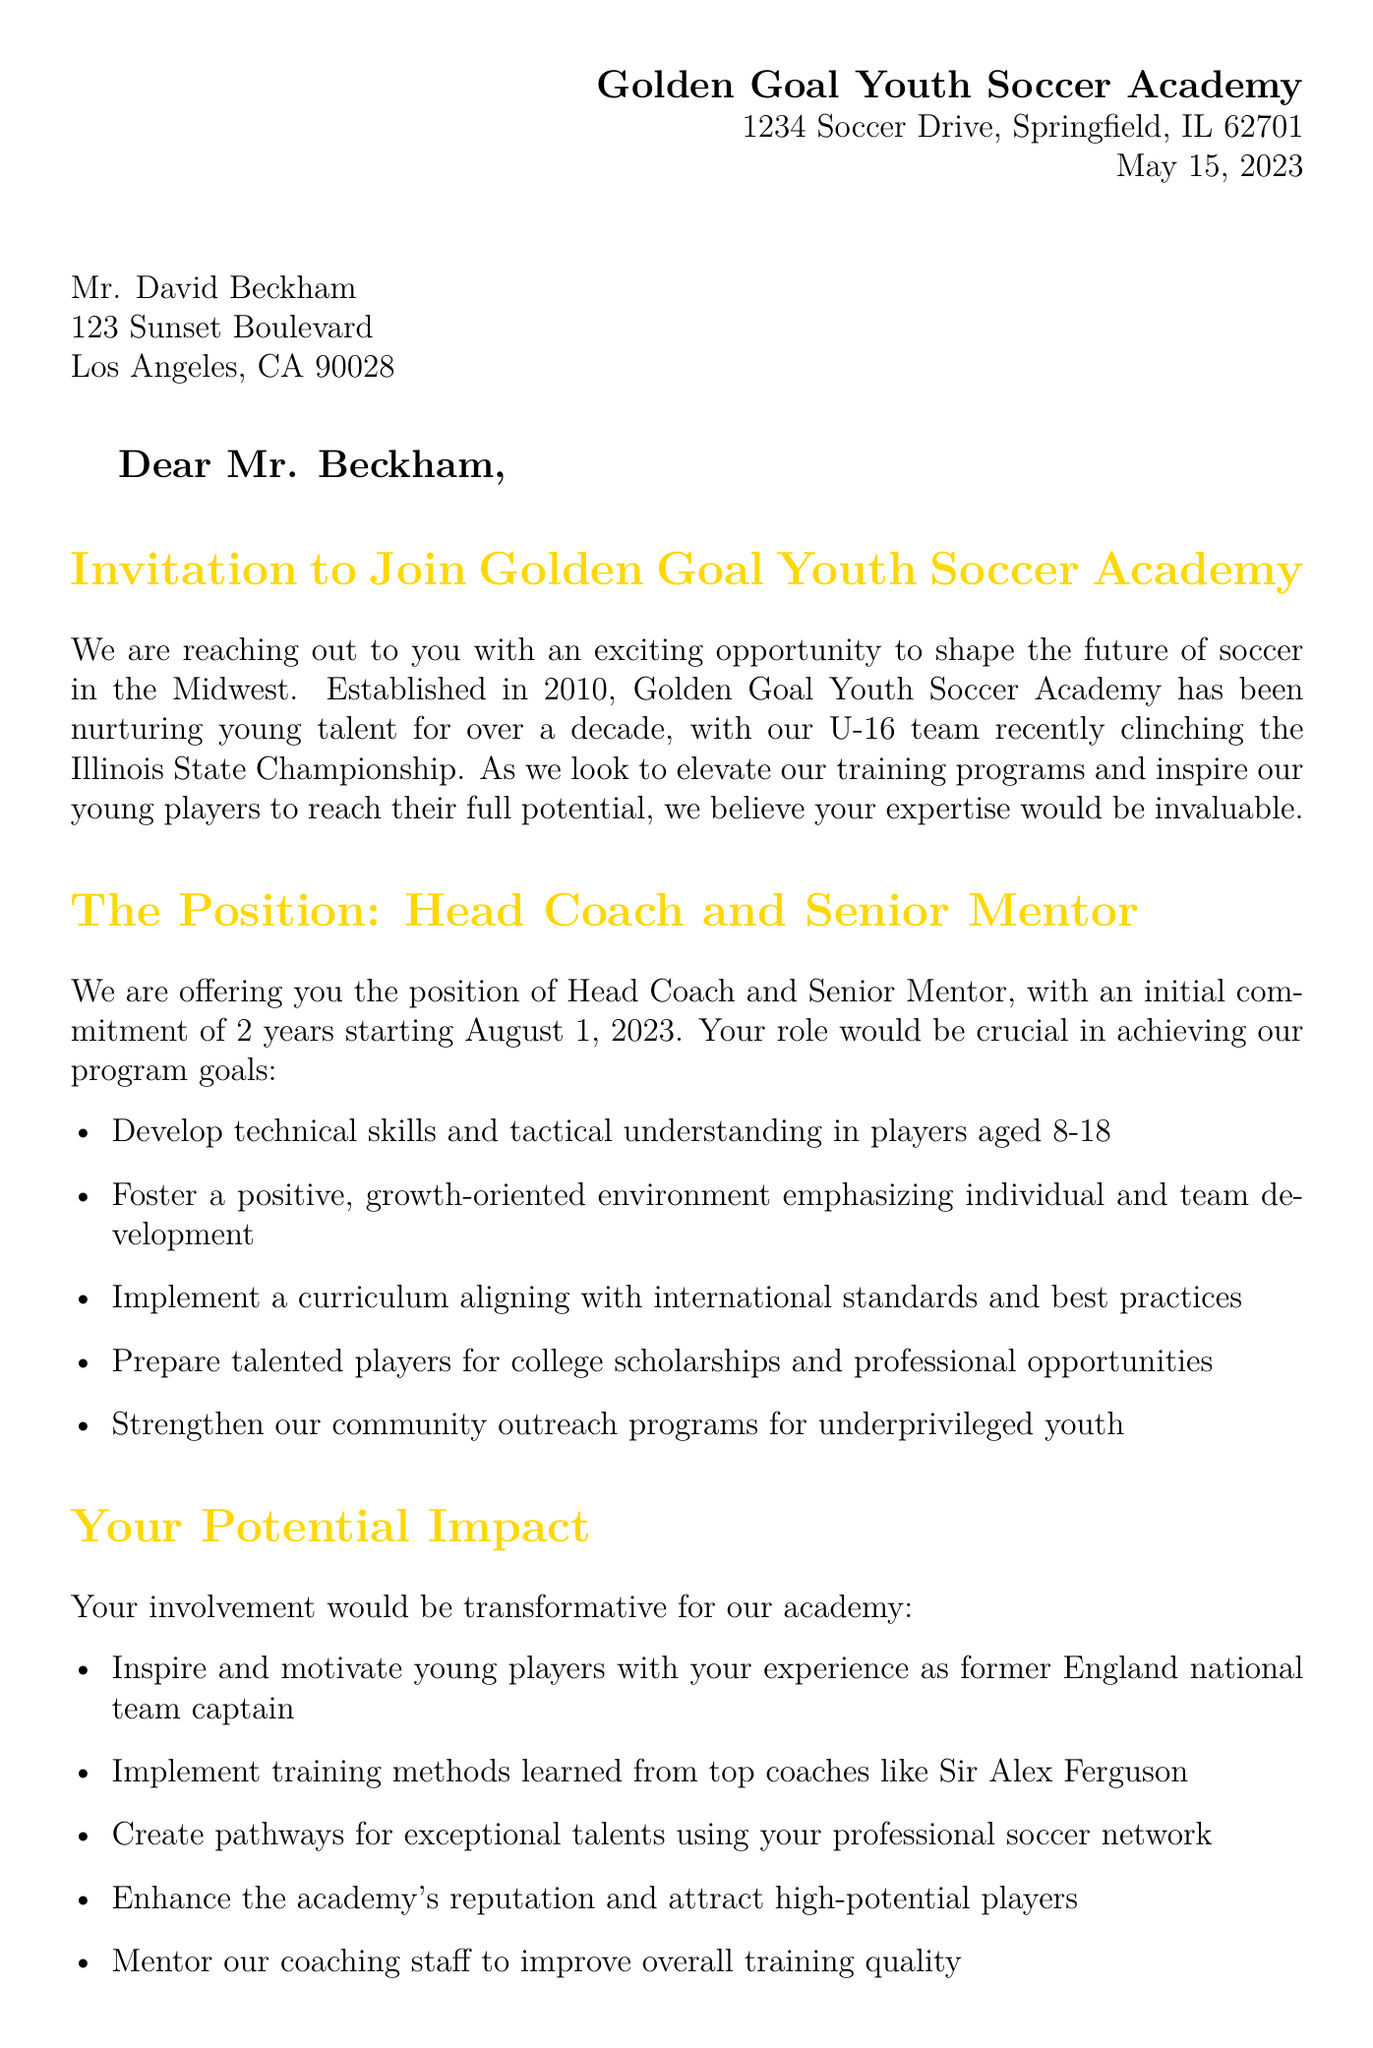What is the name of the academy? The name of the academy is mentioned at the beginning of the document as Golden Goal Youth Soccer Academy.
Answer: Golden Goal Youth Soccer Academy What is Mr. Beckham's address? Mr. Beckham's address is provided in the salutation section of the letter.
Answer: 123 Sunset Boulevard, Los Angeles, CA 90028 When was the letter dated? The date of the letter is stated in the letterhead section.
Answer: May 15, 2023 What position is being offered? The position offered is described in the request section of the letter.
Answer: Head Coach and Senior Mentor What is the initial commitment duration? The commitment duration is indicated under the request section.
Answer: 2 years What is one of the potential impacts mentioned? The document lists several potential impacts, one of which is that his experience could motivate young players.
Answer: Inspire and motivate young players What type of compensation package is offered? The document refers to the compensation package offered to Mr. Beckham.
Answer: Competitive compensation package Who is the author of the testimonial? The testimonial includes a quote about the academy's dream of having Mr. Beckham as a coach and is attributed to an individual.
Answer: Sarah Johnson What is the contact information for arranging a meeting? The call to action section provides contact details for arranging a meeting.
Answer: sarah.johnson@goldengoalacademy.com or (217) 555-1234 